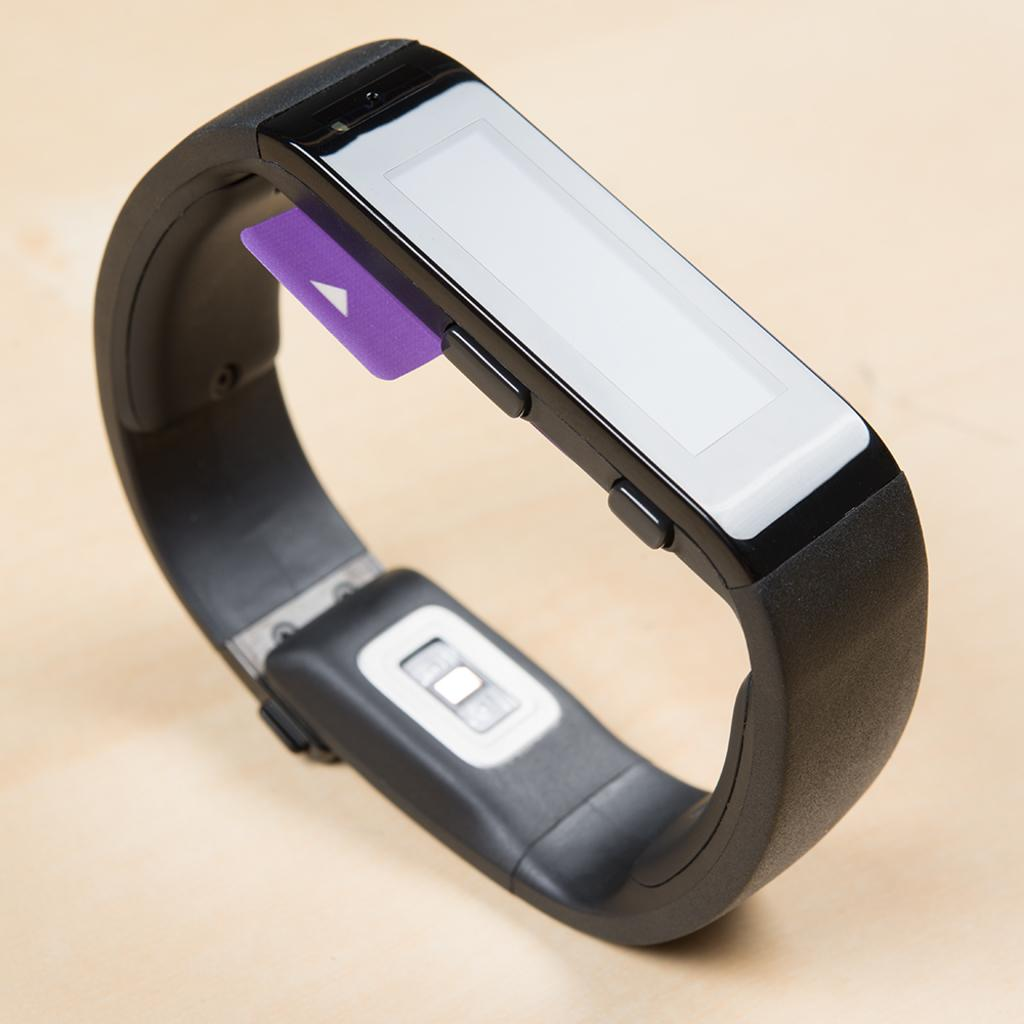What device is visible in the image? There is a smart band in the image. Where is the smart band located? The smart band is on a table. What type of wine is being served in the image? There is no wine present in the image; it features a smart band on a table. What acoustics can be heard in the image? There is no audio or acoustics present in the image, as it is a still image of a smart band on a table. 